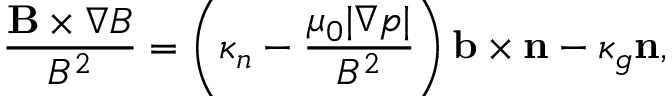Convert formula to latex. <formula><loc_0><loc_0><loc_500><loc_500>\frac { B \times \nabla B } { B ^ { 2 } } = \left ( \kappa _ { n } - \frac { \mu _ { 0 } | \nabla p | } { B ^ { 2 } } \right ) b \times n - \kappa _ { g } n ,</formula> 